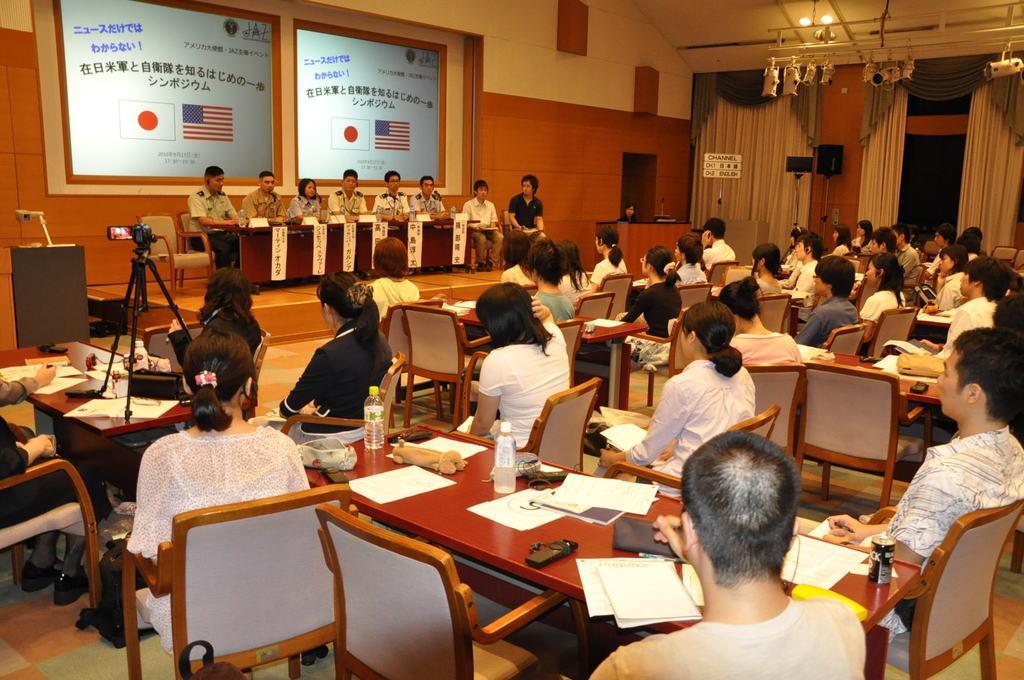Describe this image in one or two sentences. In this picture there are many people sitting in the chairs around a table on which some papers, remotes were placed. In this room there are men and women in this group. There is a video camera with a tripod here. In the back ground there are some people sitting in the chairs in front of a table on the stage. In the background there is a wall here and some curtains. 